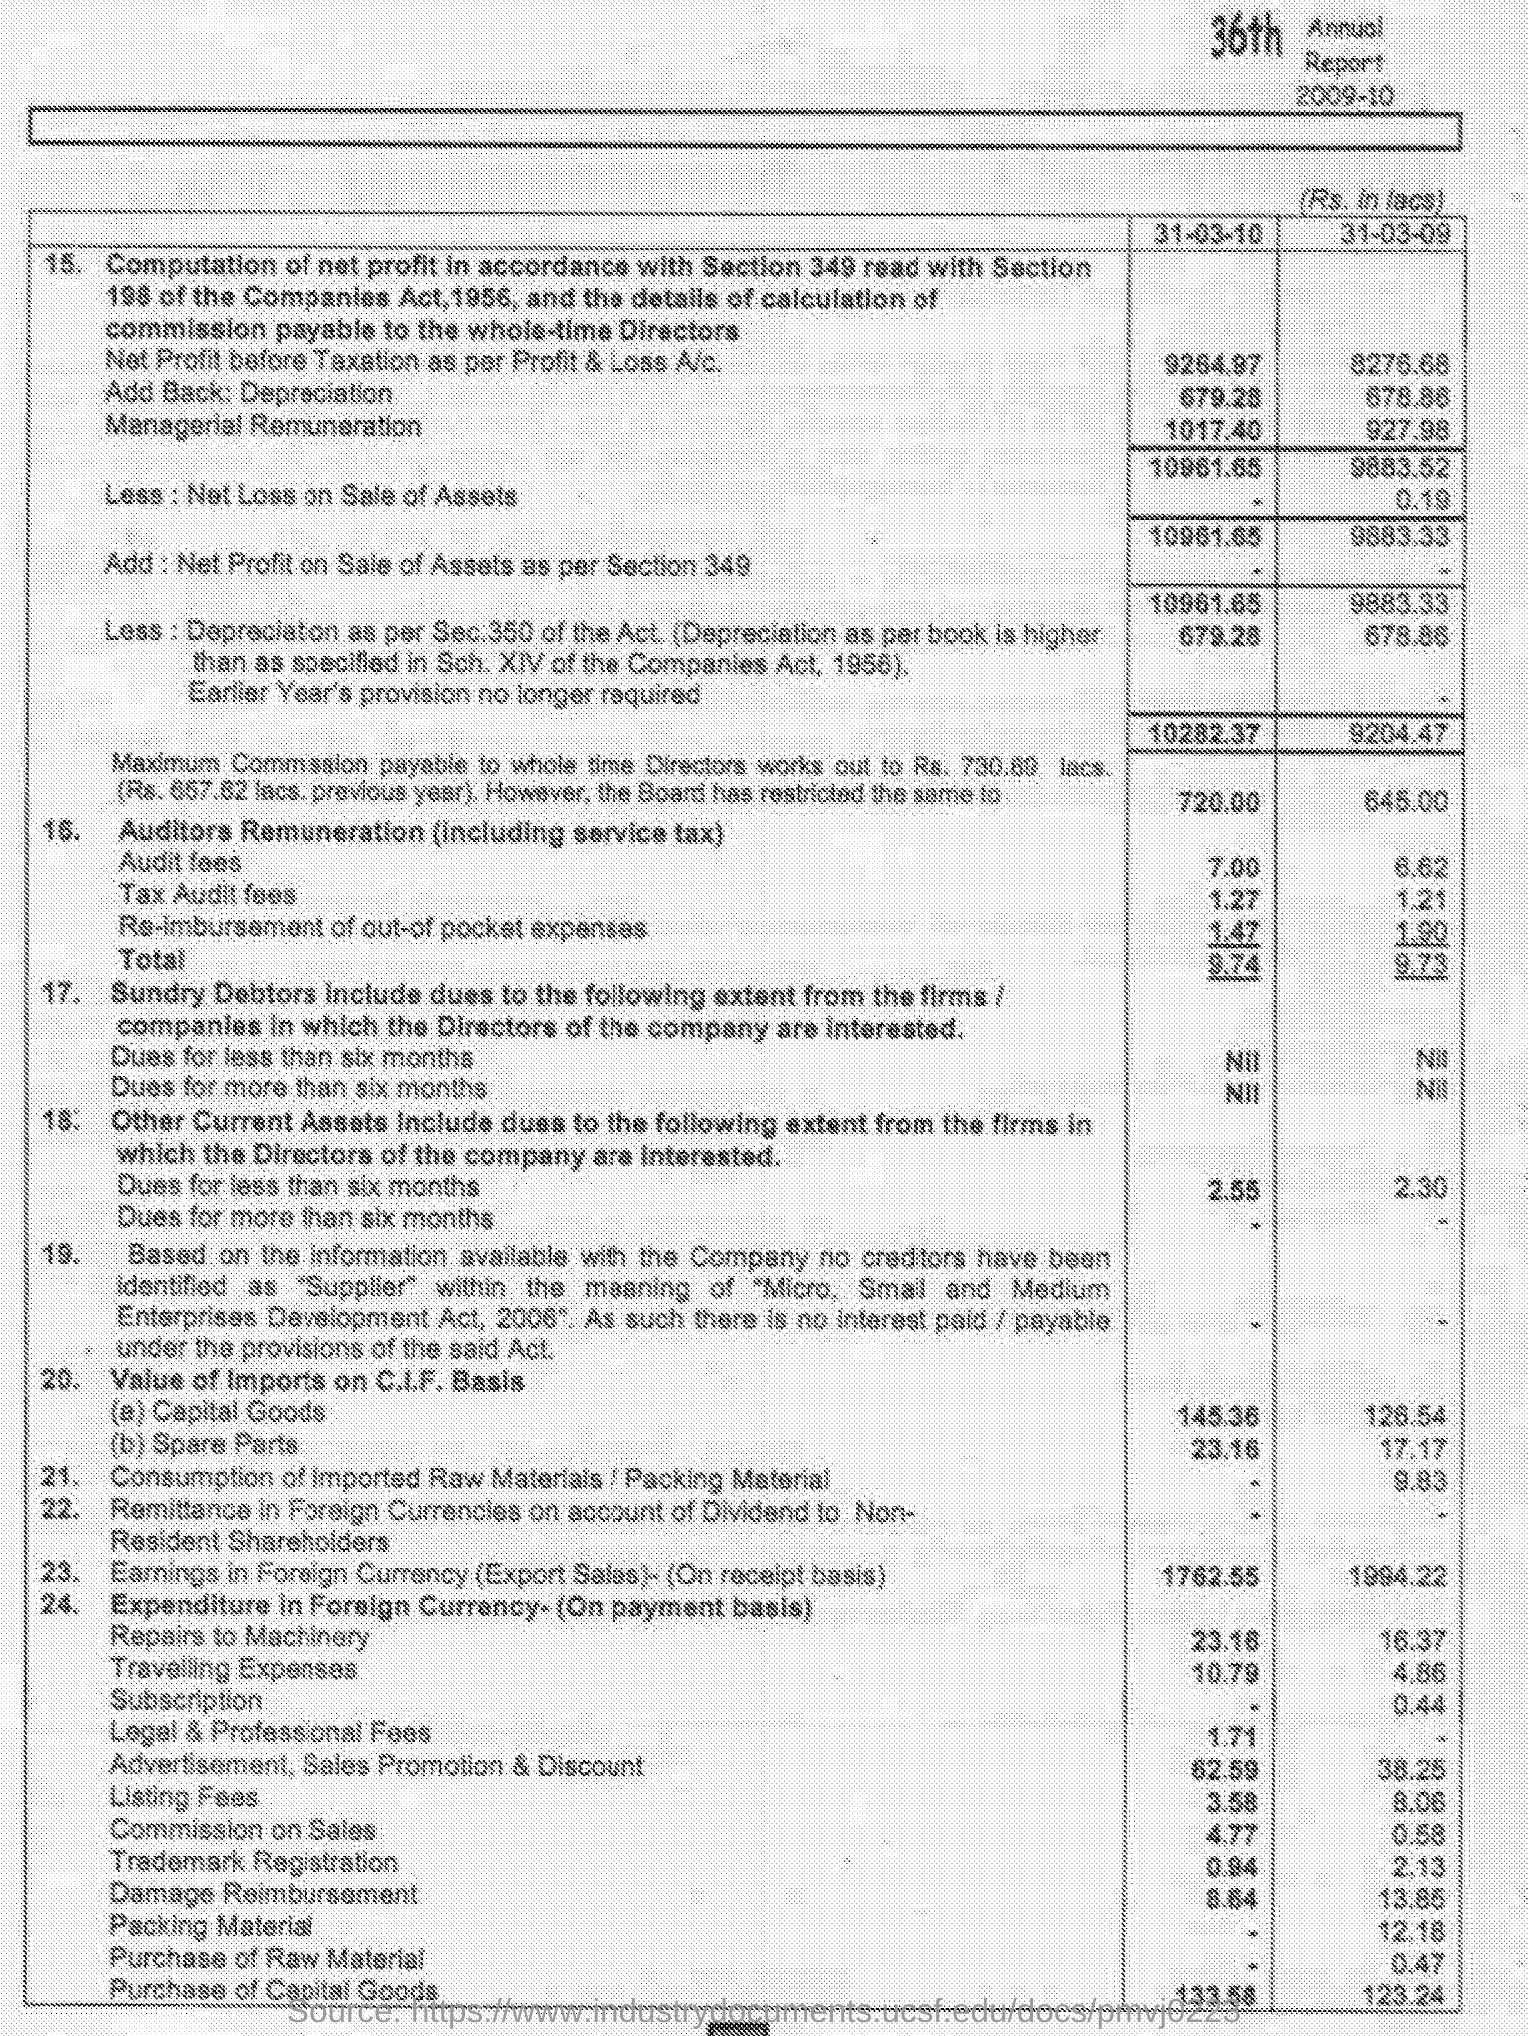What is the audit fees on 31-03-10?
Your answer should be compact. 7.00. What is the tax audit fees on 31-03-09?
Your answer should be very brief. 1.21. What is the value of imports on the C.I.F basis for capital goods on 31-03-10?
Your answer should be compact. 145.36. What is the value of imports on the C.I.F basis for spare parts on 31-03-09?
Offer a very short reply. 17.17. What is the consumption of imported raw materials on 31-03-09?
Offer a very short reply. 9.83. 